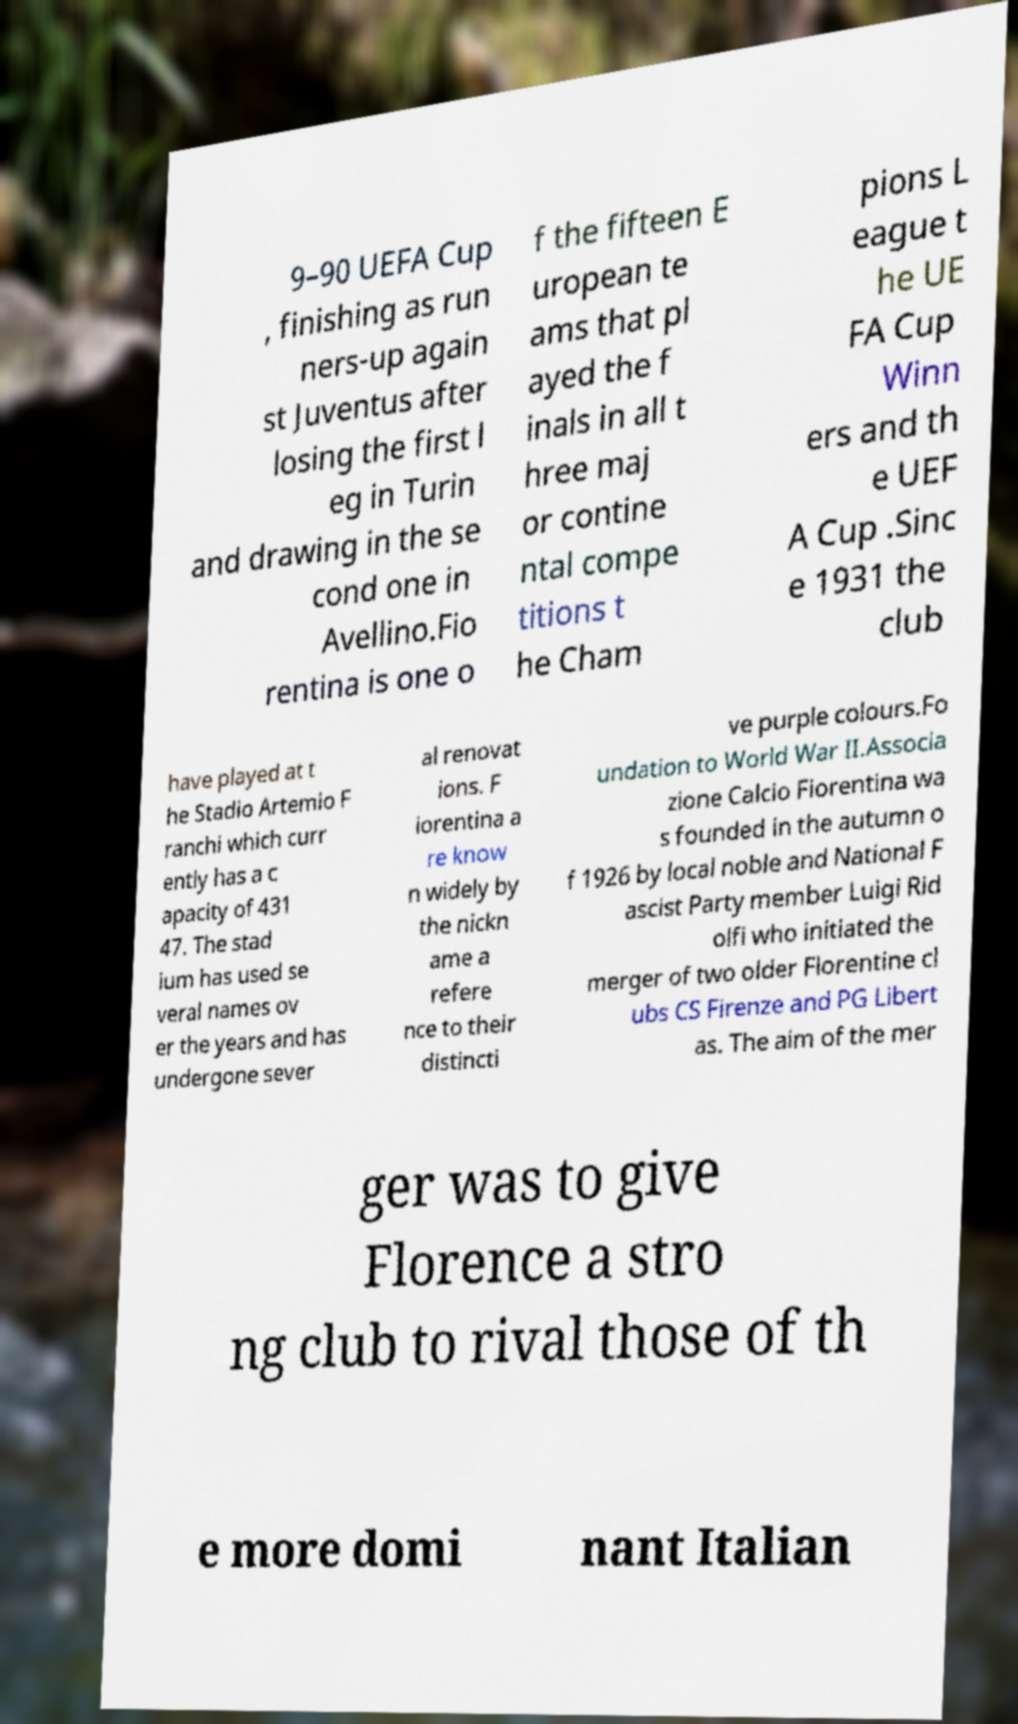Could you extract and type out the text from this image? 9–90 UEFA Cup , finishing as run ners-up again st Juventus after losing the first l eg in Turin and drawing in the se cond one in Avellino.Fio rentina is one o f the fifteen E uropean te ams that pl ayed the f inals in all t hree maj or contine ntal compe titions t he Cham pions L eague t he UE FA Cup Winn ers and th e UEF A Cup .Sinc e 1931 the club have played at t he Stadio Artemio F ranchi which curr ently has a c apacity of 431 47. The stad ium has used se veral names ov er the years and has undergone sever al renovat ions. F iorentina a re know n widely by the nickn ame a refere nce to their distincti ve purple colours.Fo undation to World War II.Associa zione Calcio Fiorentina wa s founded in the autumn o f 1926 by local noble and National F ascist Party member Luigi Rid olfi who initiated the merger of two older Florentine cl ubs CS Firenze and PG Libert as. The aim of the mer ger was to give Florence a stro ng club to rival those of th e more domi nant Italian 